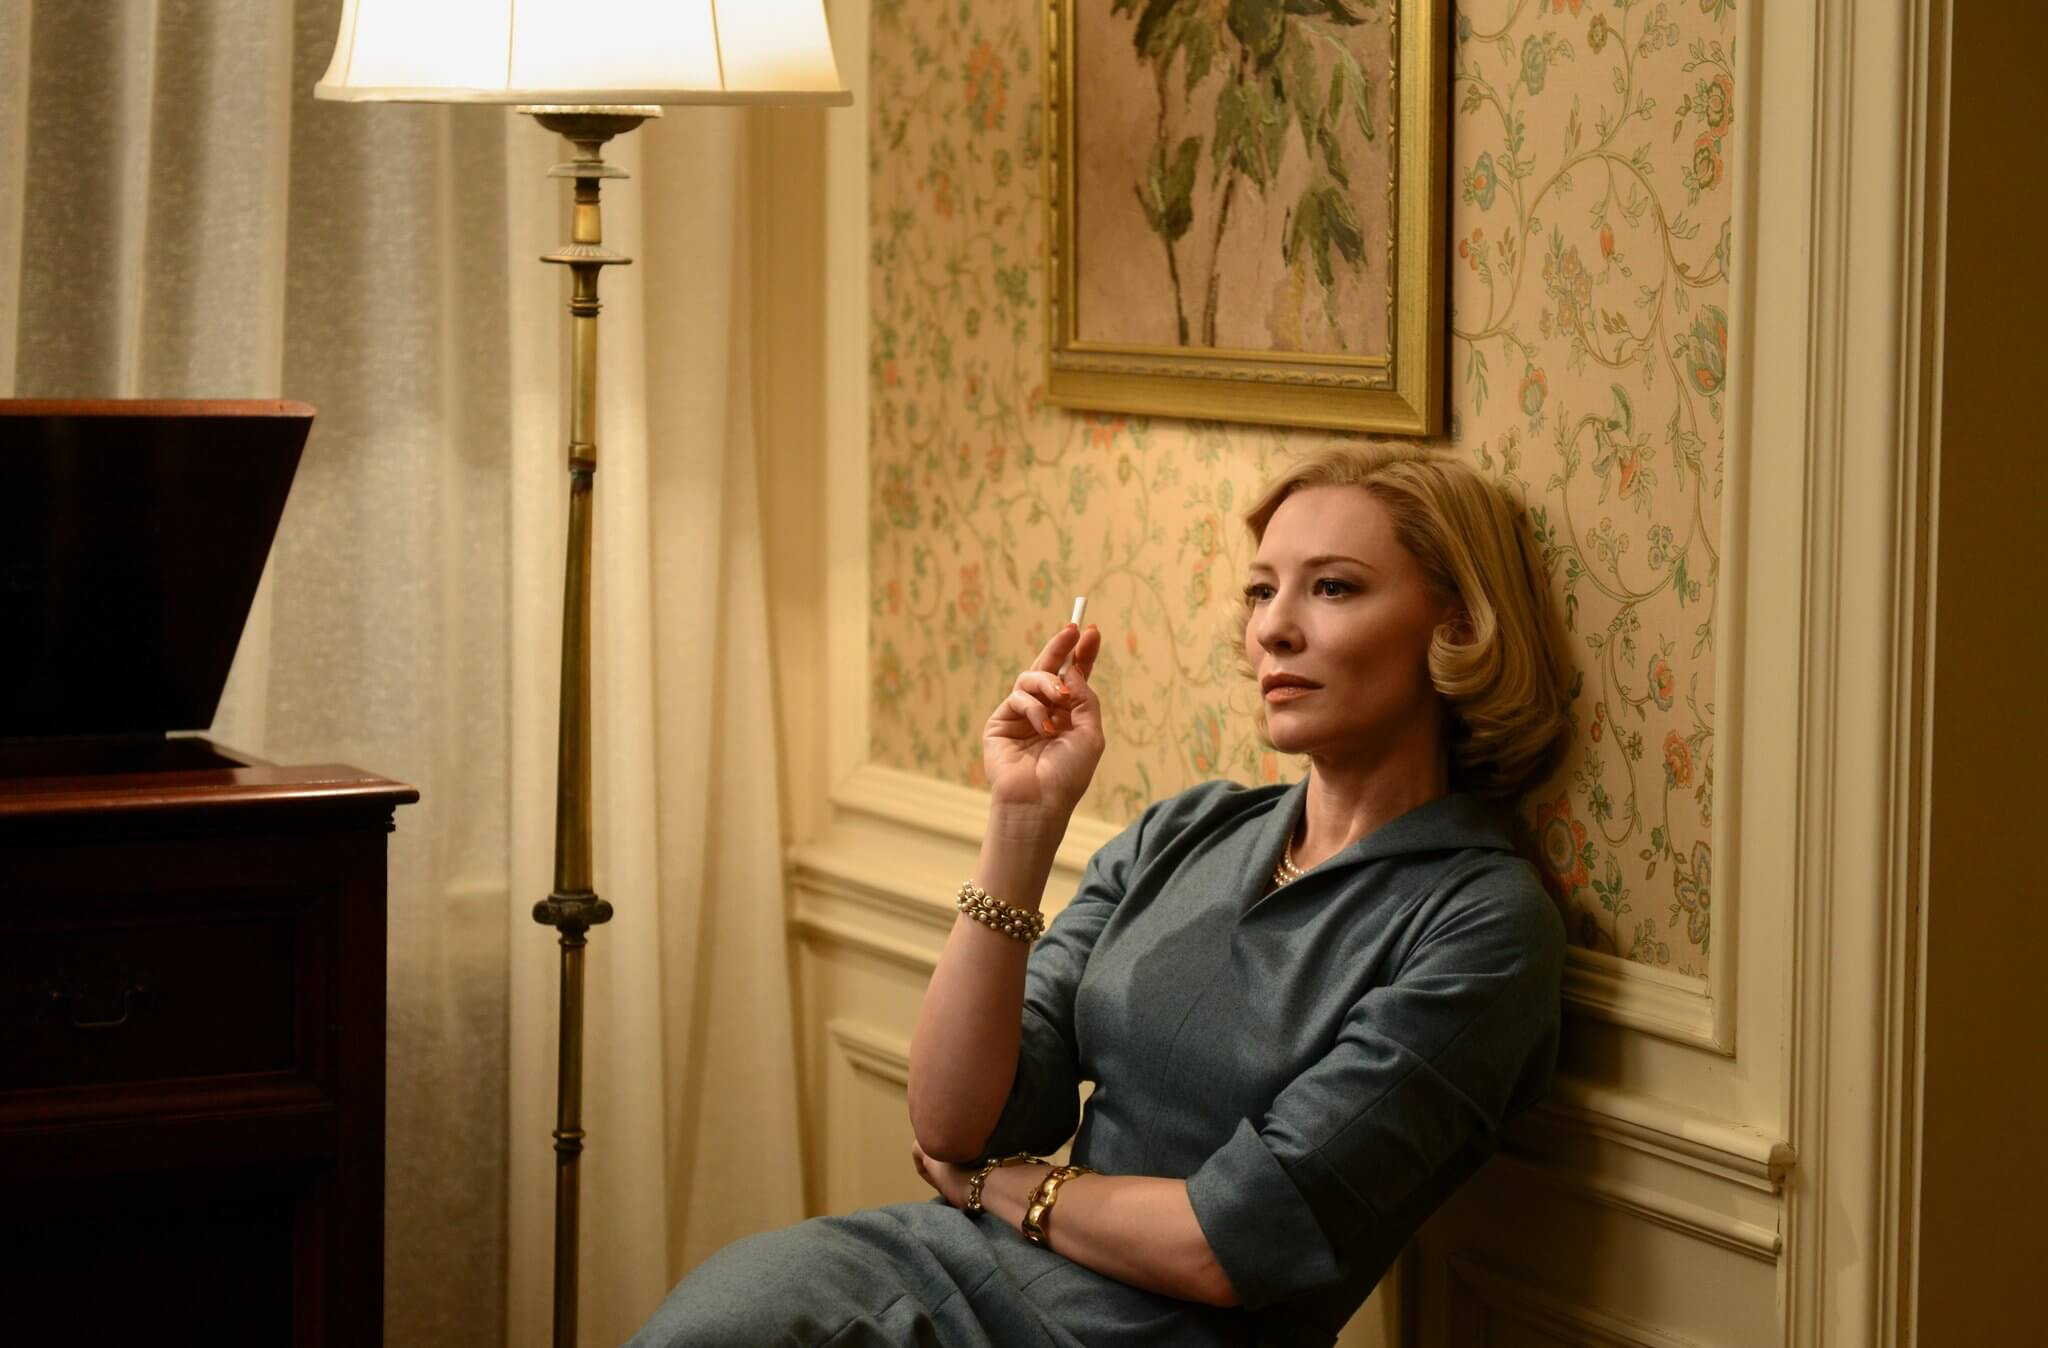What might be the significance of the floral wallpaper in the background? The floral wallpaper in the background could symbolize a contrast between the character's current state and the vibrant life the flowers represent. It might also indicate a traditional or dated setting, suggesting a nostalgia or longing for the past within the narrative. Additionally, the recurring nature of the floral patterns could denote the repetitive elements in her life or story. 